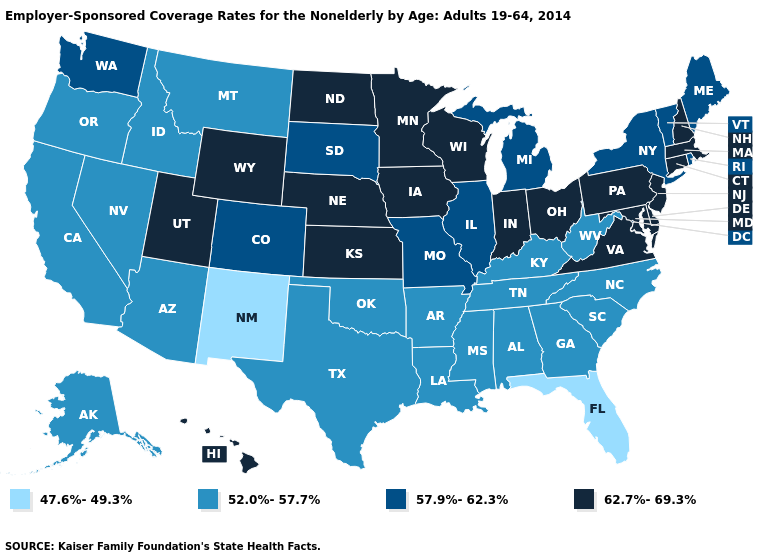What is the value of North Carolina?
Be succinct. 52.0%-57.7%. Which states hav the highest value in the MidWest?
Be succinct. Indiana, Iowa, Kansas, Minnesota, Nebraska, North Dakota, Ohio, Wisconsin. Which states hav the highest value in the South?
Be succinct. Delaware, Maryland, Virginia. Which states have the lowest value in the South?
Be succinct. Florida. Does Maryland have the lowest value in the USA?
Write a very short answer. No. What is the value of Washington?
Keep it brief. 57.9%-62.3%. What is the value of Tennessee?
Write a very short answer. 52.0%-57.7%. How many symbols are there in the legend?
Give a very brief answer. 4. Does Rhode Island have the highest value in the Northeast?
Quick response, please. No. Which states have the highest value in the USA?
Answer briefly. Connecticut, Delaware, Hawaii, Indiana, Iowa, Kansas, Maryland, Massachusetts, Minnesota, Nebraska, New Hampshire, New Jersey, North Dakota, Ohio, Pennsylvania, Utah, Virginia, Wisconsin, Wyoming. What is the value of Rhode Island?
Short answer required. 57.9%-62.3%. Does Alaska have the lowest value in the USA?
Keep it brief. No. What is the lowest value in states that border Maine?
Write a very short answer. 62.7%-69.3%. 